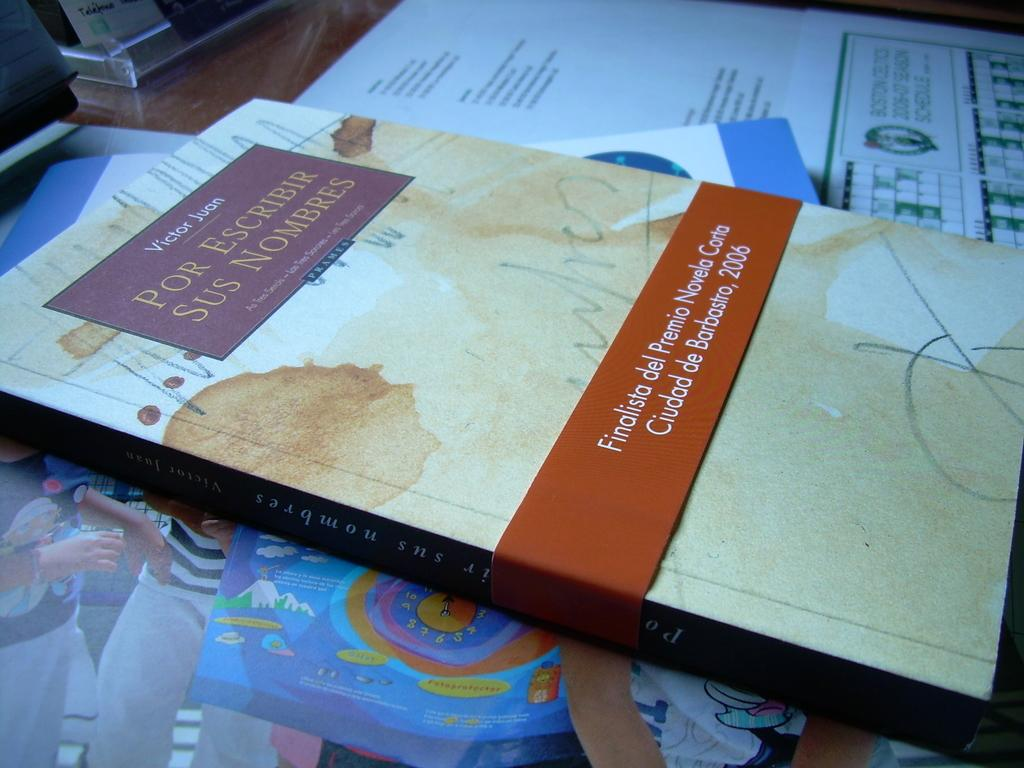<image>
Give a short and clear explanation of the subsequent image. A brown book called Por Escribir Sus Nombres. 